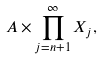<formula> <loc_0><loc_0><loc_500><loc_500>A \times \prod _ { j = n + 1 } ^ { \infty } X _ { j } ,</formula> 